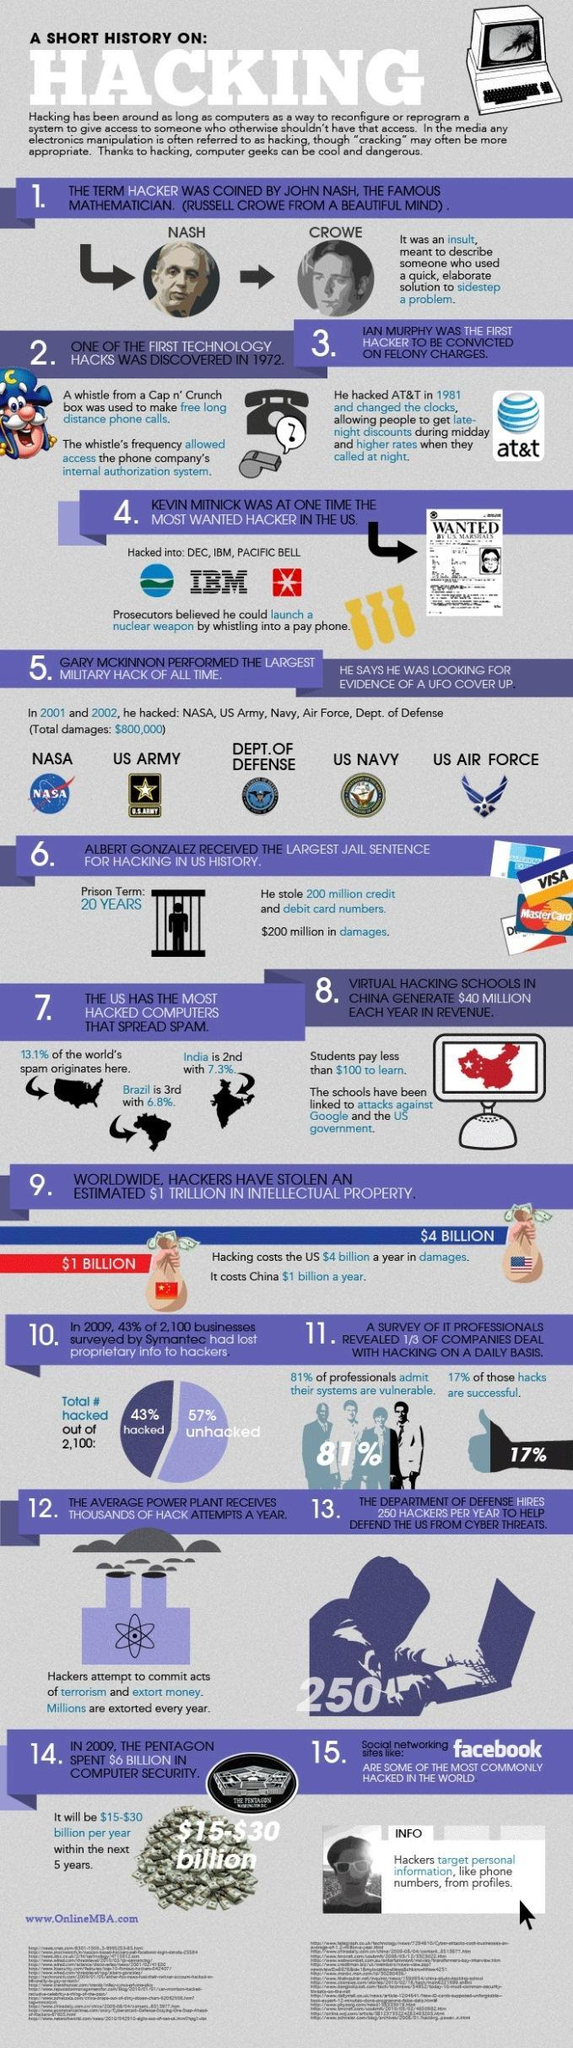What percent of hacks were unsuccessful?
Answer the question with a short phrase. 83% For how long was Albert Gonzalez in jail? 20 YEARS What percent of spam is from the US? 13.1% 